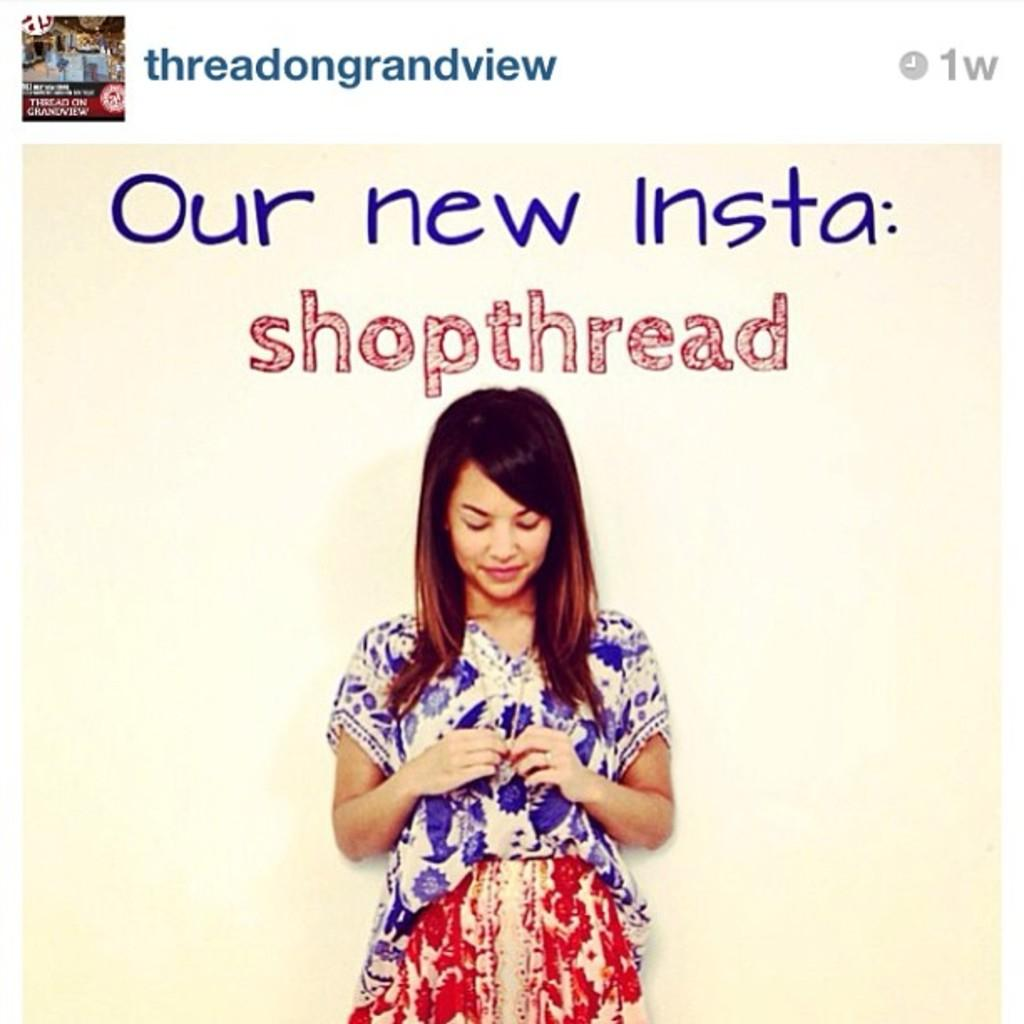What is depicted on the poster in the image? There is a poster of a person in the image. What else can be seen in the image besides the poster? There is text in the image. Can you describe the layout of the image? There is an image on the top side of the picture. What type of plantation is visible in the image? There is no plantation present in the image. How does the person's behavior change throughout the image? The image only shows a poster of a person, so there is no behavior to observe or analyze. 